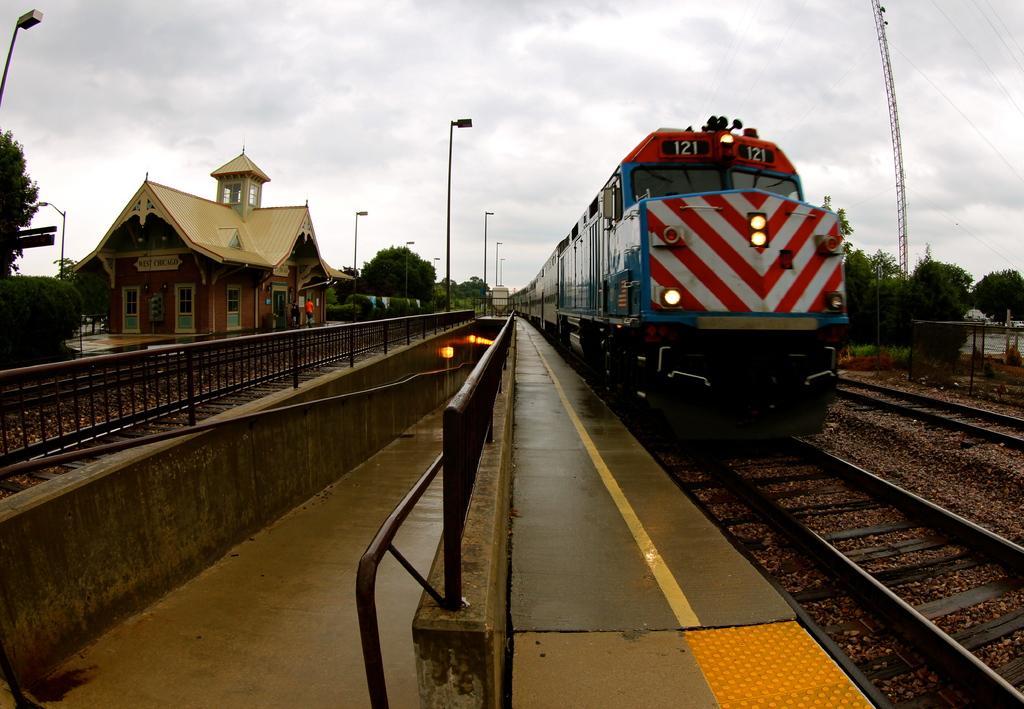In one or two sentences, can you explain what this image depicts? In this picture we can observe a railway station. There is a platform. We can observe a train on the railway track. There is a black color railing. We can observe a subway. On the left side we can observe a house. There are some poles and trees in this picture. In the background there is a sky with some clouds. 